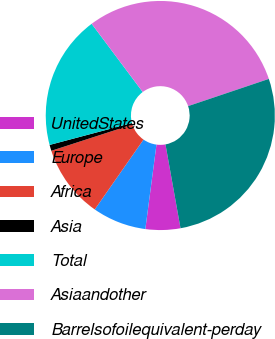Convert chart. <chart><loc_0><loc_0><loc_500><loc_500><pie_chart><fcel>UnitedStates<fcel>Europe<fcel>Africa<fcel>Asia<fcel>Total<fcel>Asiaandother<fcel>Barrelsofoilequivalent-perday<nl><fcel>4.91%<fcel>7.61%<fcel>10.32%<fcel>0.85%<fcel>18.91%<fcel>30.05%<fcel>27.35%<nl></chart> 